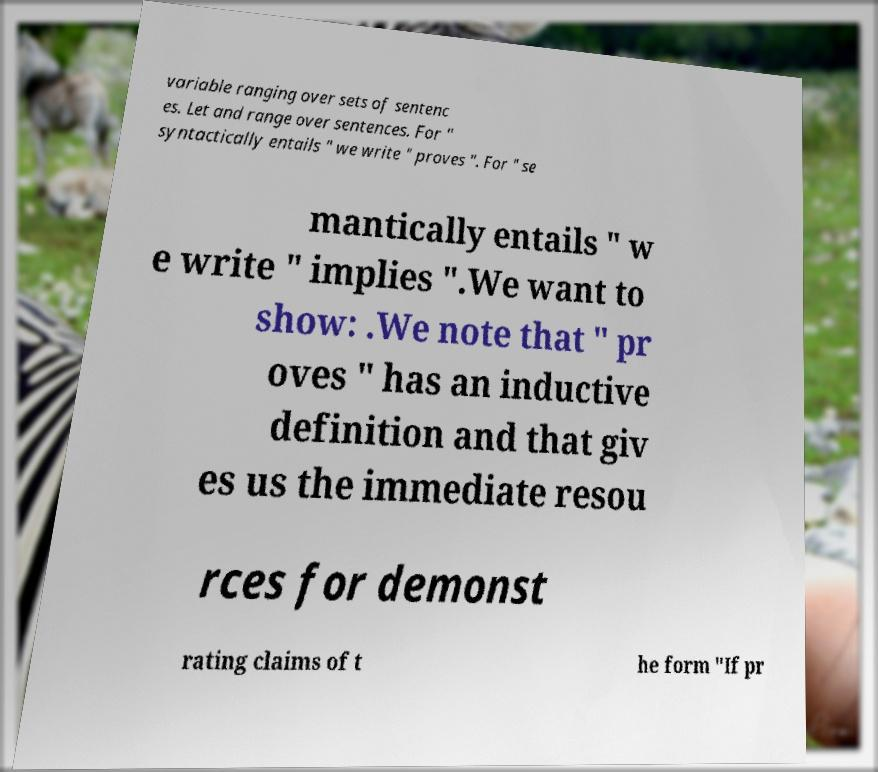There's text embedded in this image that I need extracted. Can you transcribe it verbatim? variable ranging over sets of sentenc es. Let and range over sentences. For " syntactically entails " we write " proves ". For " se mantically entails " w e write " implies ".We want to show: .We note that " pr oves " has an inductive definition and that giv es us the immediate resou rces for demonst rating claims of t he form "If pr 